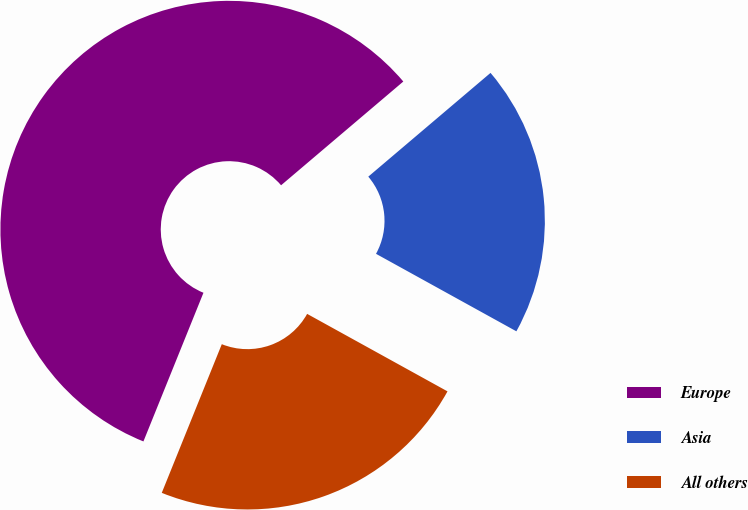Convert chart. <chart><loc_0><loc_0><loc_500><loc_500><pie_chart><fcel>Europe<fcel>Asia<fcel>All others<nl><fcel>57.69%<fcel>19.23%<fcel>23.08%<nl></chart> 